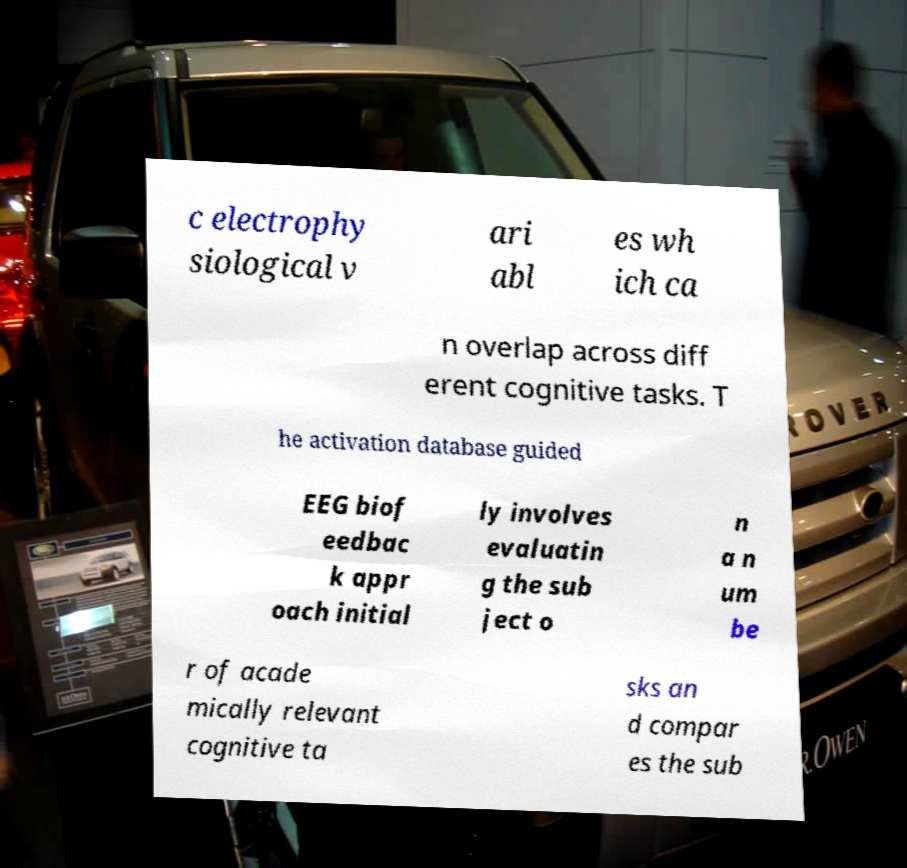Please read and relay the text visible in this image. What does it say? c electrophy siological v ari abl es wh ich ca n overlap across diff erent cognitive tasks. T he activation database guided EEG biof eedbac k appr oach initial ly involves evaluatin g the sub ject o n a n um be r of acade mically relevant cognitive ta sks an d compar es the sub 